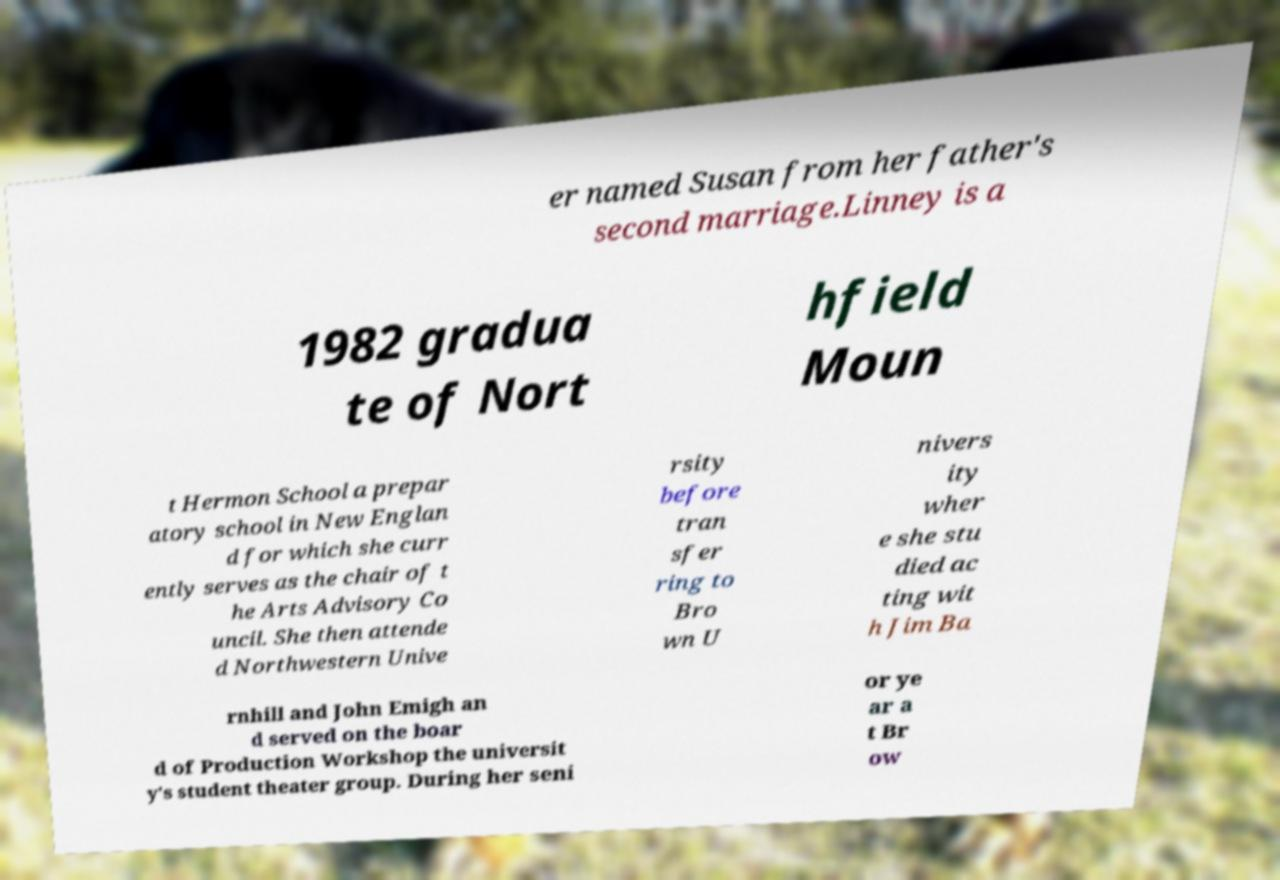Could you extract and type out the text from this image? er named Susan from her father's second marriage.Linney is a 1982 gradua te of Nort hfield Moun t Hermon School a prepar atory school in New Englan d for which she curr ently serves as the chair of t he Arts Advisory Co uncil. She then attende d Northwestern Unive rsity before tran sfer ring to Bro wn U nivers ity wher e she stu died ac ting wit h Jim Ba rnhill and John Emigh an d served on the boar d of Production Workshop the universit y's student theater group. During her seni or ye ar a t Br ow 